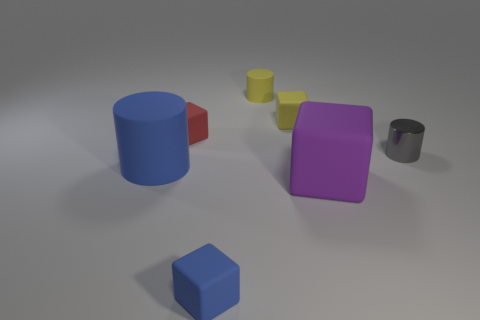What shape is the yellow thing that is in front of the small cylinder that is on the left side of the tiny gray thing?
Ensure brevity in your answer.  Cube. There is a big block; is its color the same as the cylinder that is right of the yellow cylinder?
Make the answer very short. No. Are there any other things that have the same material as the tiny gray object?
Your answer should be compact. No. What is the shape of the tiny blue rubber thing?
Offer a terse response. Cube. What size is the blue rubber thing that is behind the tiny rubber block in front of the gray metallic thing?
Your answer should be compact. Large. Are there the same number of gray objects that are to the left of the large matte cylinder and big purple matte blocks that are right of the tiny gray metallic thing?
Provide a succinct answer. Yes. There is a block that is in front of the gray shiny cylinder and behind the blue matte cube; what is its material?
Provide a short and direct response. Rubber. Does the yellow rubber block have the same size as the gray cylinder behind the purple rubber thing?
Your answer should be very brief. Yes. What number of other things are the same color as the small shiny cylinder?
Offer a terse response. 0. Is the number of tiny yellow rubber cubes left of the big blue cylinder greater than the number of purple things?
Make the answer very short. No. 